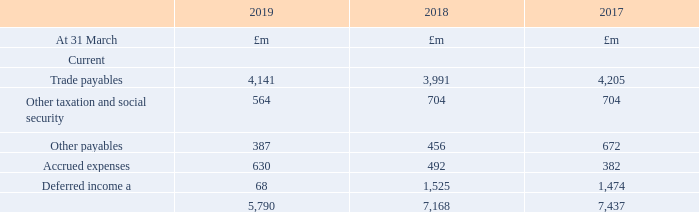18. Trade and other payables  Significant accounting policies that apply to trade and other payables We initially recognise trade and other payables at fair value, which is usually the original invoiced amount. We subsequently carry them at amortised cost using the effective interest method.
a Deferred income recognised in prior periods has substantially been reclassified to contract liabilities on adoption of IFRS 15, see notes 1 and 2. The remaining balance includes £51m (2017/18: £132m, 2016/17: £71m) current and £586m (2017/18: £404m, 2016/17: £375m) non-current liabilities relating to the Broadband Delivery UK programme, for which grants received by the group may be subject to re-investment or repayment depending on the level of take-up.
b Other payables relate to operating lease liabilities and deferred gains on a 2001 sale and finance leaseback transaction.
What was the impact on deferred income on on adoption of IFRS 15? Deferred income recognised in prior periods has substantially been reclassified to contract liabilities on adoption of ifrs 15. What was the remaining balance current liabilities relating to the Broadband Delivery UK programme? The remaining balance includes £51m (2017/18: £132m, 2016/17: £71m) current. What is the Other payables for 2019?
Answer scale should be: million. 387. What is the change in Current: Trade payables from 2018 to 2019?
Answer scale should be: million. 4,141-3,991
Answer: 150. What is the change in Current: Other taxation and social security from 2019 to 2018?
Answer scale should be: million. 564-704
Answer: -140. What is the change in Current: Other payables from 2019 to 2018?
Answer scale should be: million. 387-456
Answer: -69. 